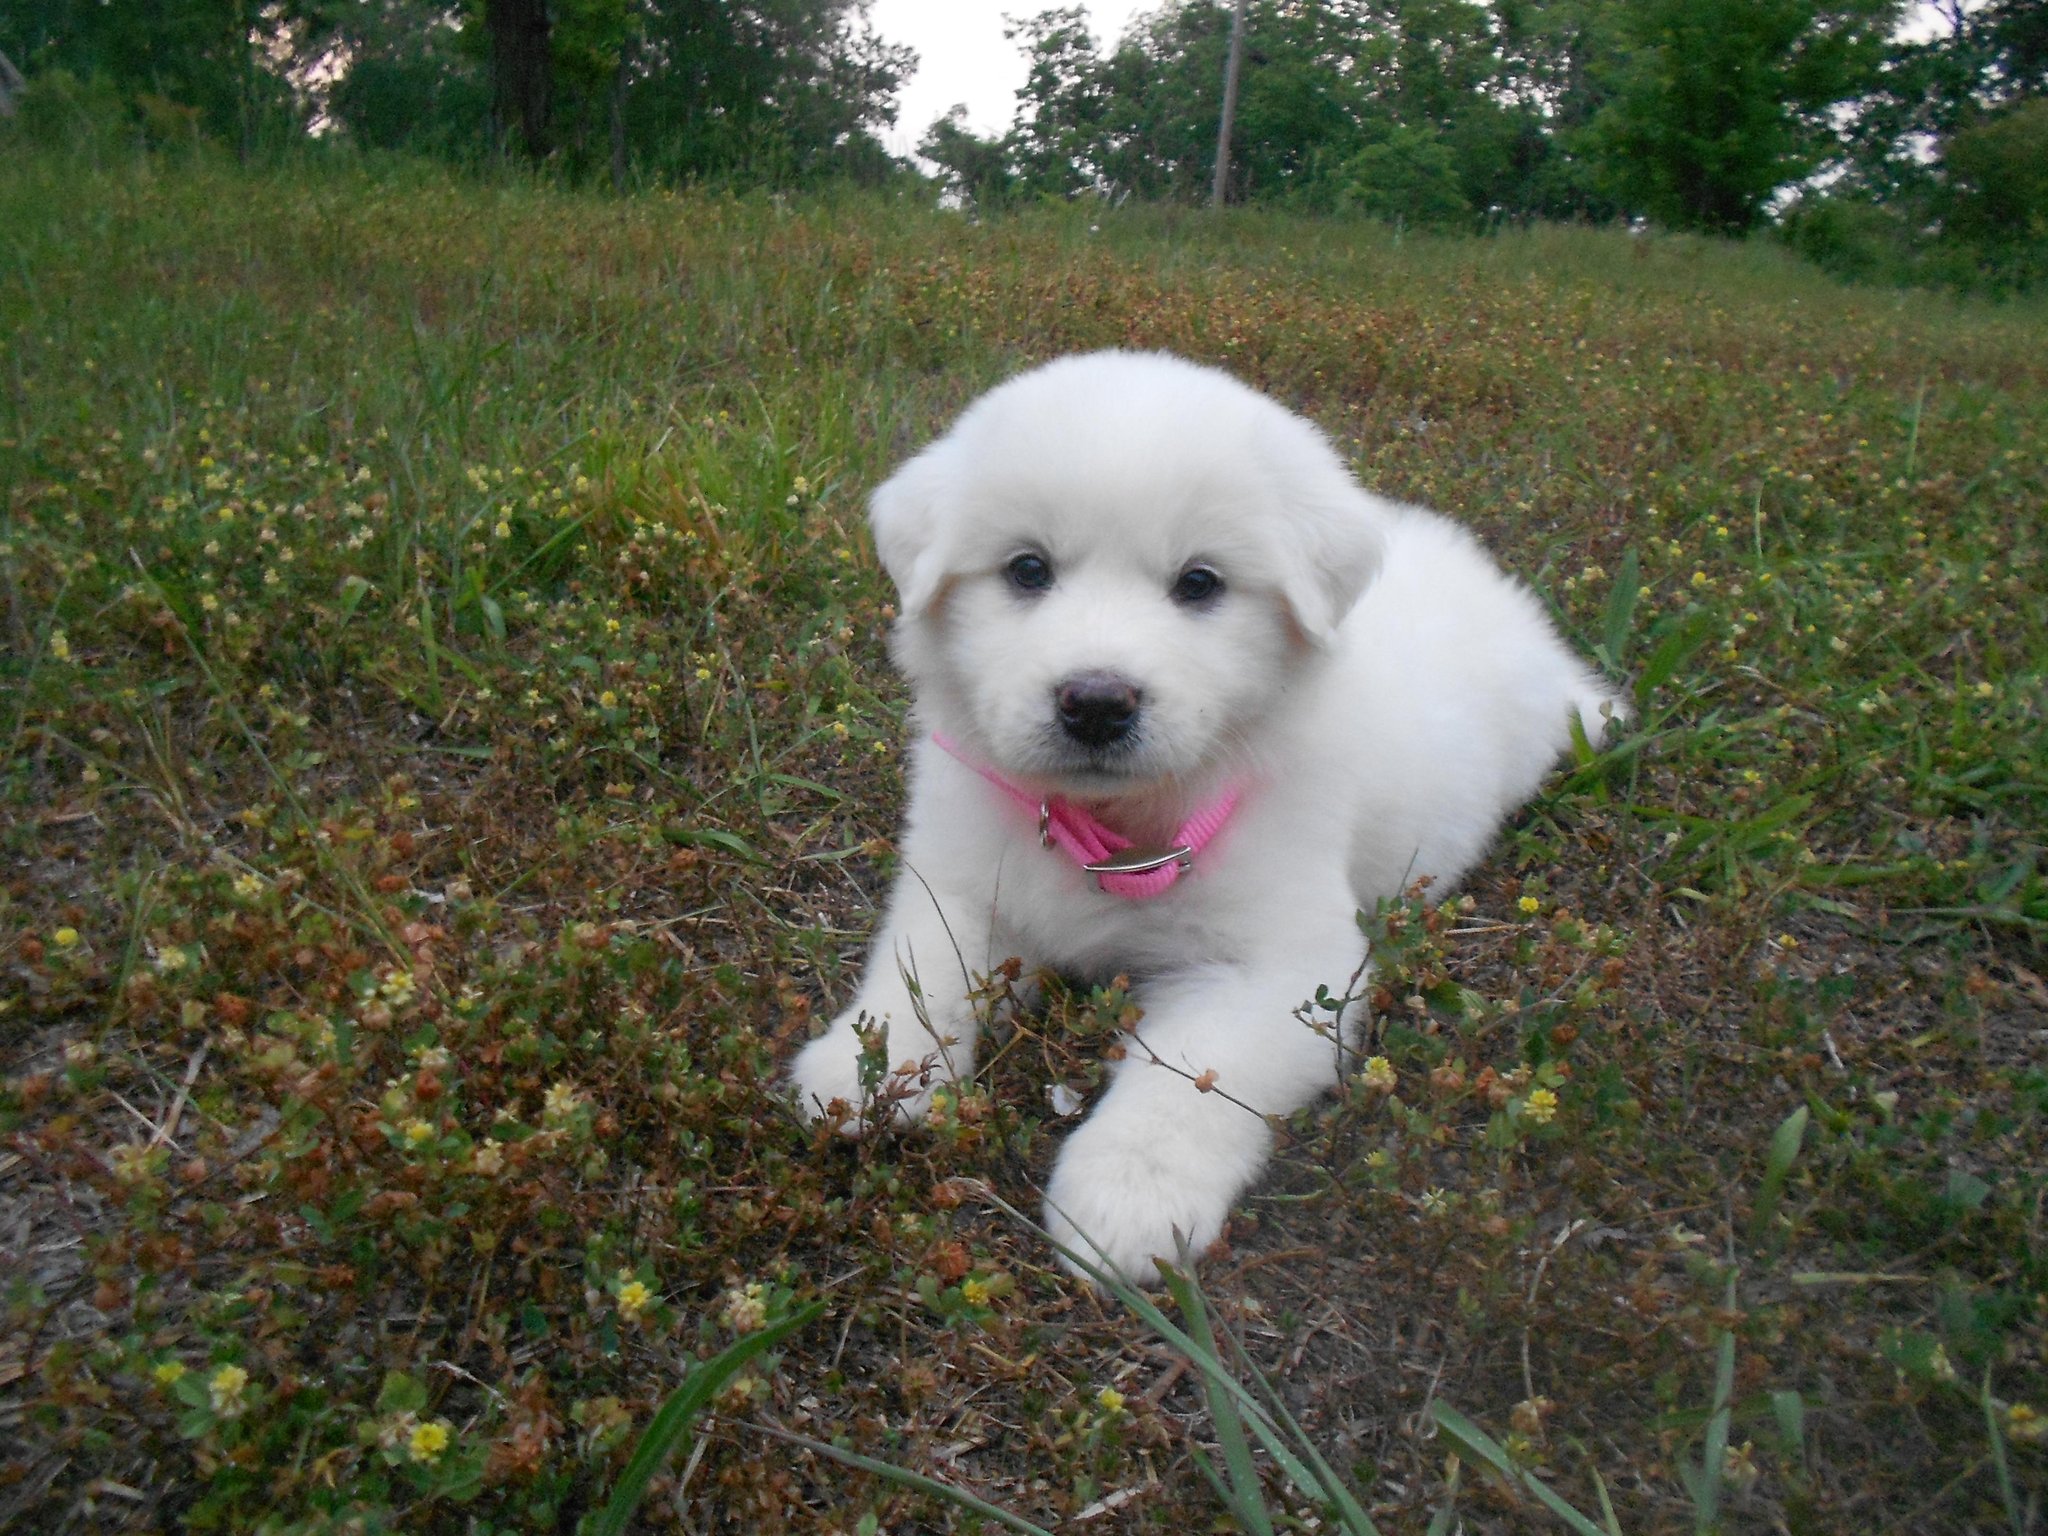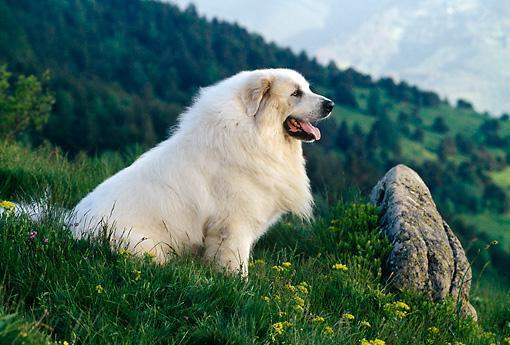The first image is the image on the left, the second image is the image on the right. Considering the images on both sides, is "a dog is laying in the grass in the left image" valid? Answer yes or no. Yes. The first image is the image on the left, the second image is the image on the right. Analyze the images presented: Is the assertion "A young puppy is lying down in one of the images." valid? Answer yes or no. Yes. 